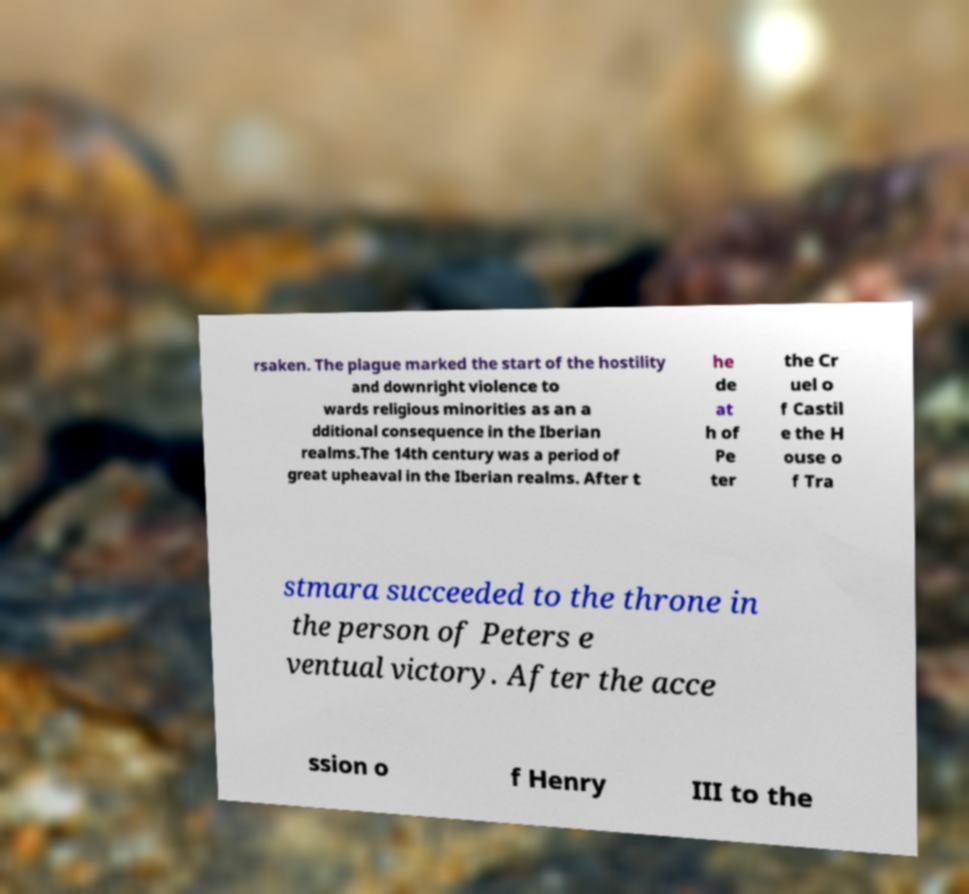I need the written content from this picture converted into text. Can you do that? rsaken. The plague marked the start of the hostility and downright violence to wards religious minorities as an a dditional consequence in the Iberian realms.The 14th century was a period of great upheaval in the Iberian realms. After t he de at h of Pe ter the Cr uel o f Castil e the H ouse o f Tra stmara succeeded to the throne in the person of Peters e ventual victory. After the acce ssion o f Henry III to the 